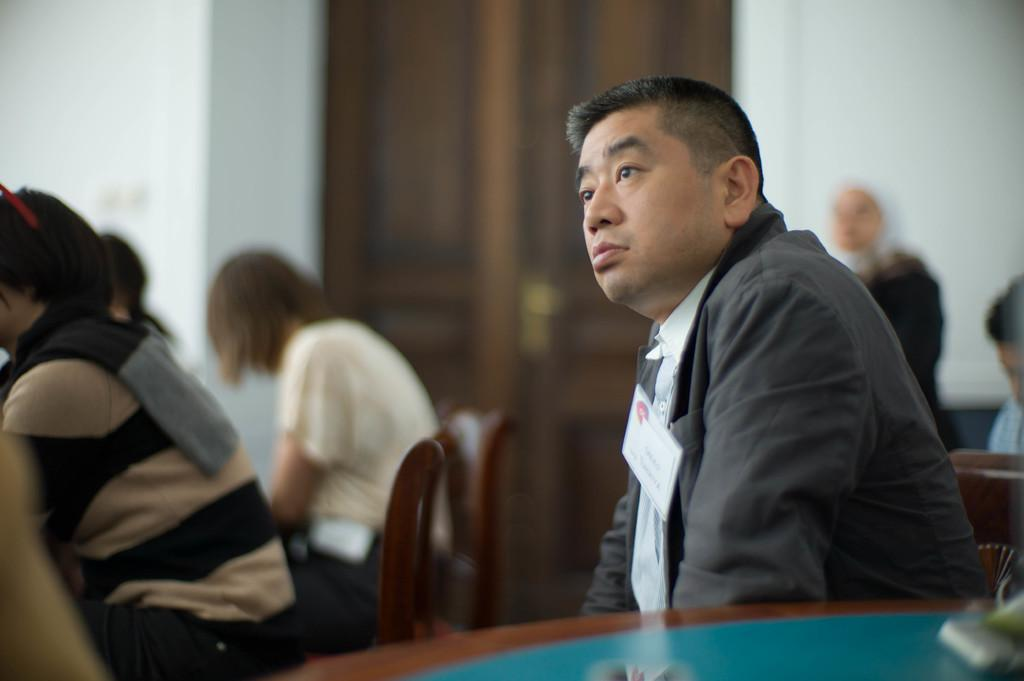Who is present in the image? There is a man and a woman in the image. What is the man doing in the image? The man is sitting on a chair in the image. In which direction is the man looking? The man is looking toward the left in the image. What is the woman wearing in the image? The woman is wearing a t-shirt in the image. What level of fiction is the man reading in the image? There is no book or any indication of reading in the image, so it is not possible to determine the level of fiction being read. 